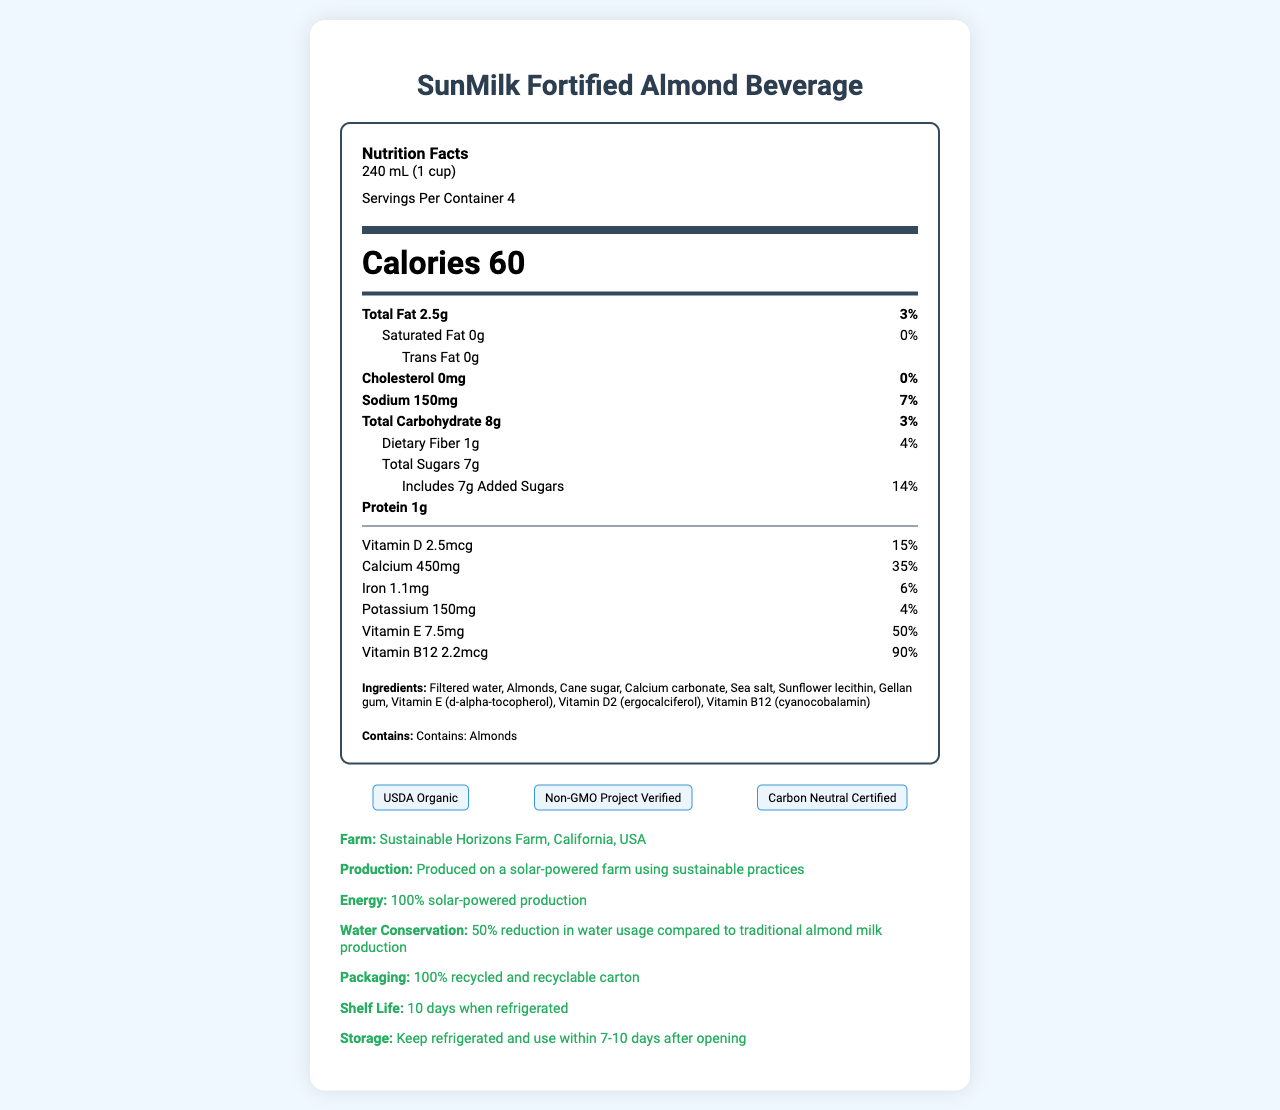what is the serving size of SunMilk Fortified Almond Beverage? The serving size is listed at the top of the nutrition facts section as "240 mL (1 cup)".
Answer: 240 mL (1 cup) How many servings are there per container? The number of servings per container is specified as "Servings Per Container: 4".
Answer: 4 How many calories are in one serving of this beverage? The calorie count per serving is displayed prominently in a larger font as "Calories 60".
Answer: 60 What is the daily value percentage of Vitamin D? The daily value percentage of Vitamin D is listed under the vitamin section as "Vitamin D 2.5mcg 15%".
Answer: 15% How much added sugar is in one serving? Under "Total Sugars", it is specified that there are "Includes 7g Added Sugars".
Answer: 7g Which vitamin has the highest daily value percentage in this beverage? Vitamin B12 has the highest daily value percentage of 90%, as shown in the document.
Answer: Vitamin B12 What certifications does this product have? A. USDA Organic B. Non-GMO Project Verified C. Carbon Neutral Certified D. All of the above The certifications section lists all three certifications: "USDA Organic", "Non-GMO Project Verified", and "Carbon Neutral Certified".
Answer: D. All of the above What is the main ingredient of SunMilk Fortified Almond Beverage? A. Cane sugar B. Almonds C. Filtered water The ingredients list shows "Filtered water" as the first ingredient, making it the main component.
Answer: C. Filtered water Does this beverage contain any saturated fat? The nutrition facts indicate "Saturated Fat 0g" and "0%" daily value, implying there is none.
Answer: No Is this product suitable for those who are allergic to almonds? The allergen statement explicitly states "Contains: Almonds", indicating it is not suitable for those with almond allergies.
Answer: No Where is the solar-powered farm located that produces this beverage? The farm location mentioned in the farm info section is "Sustainable Horizons Farm, California, USA".
Answer: Sustainable Horizons Farm, California, USA What is the overall environmental impact of the packaging used for this beverage? The document states that the packaging is "100% recycled and recyclable carton".
Answer: 100% recycled and recyclable carton Can the shelf life data of this product be confirmed from the document? The document specifies a shelf life of "10 days when refrigerated".
Answer: Yes Summarize the main points of this document. The document centers on nutritional information, sustainability practices of the farm, certifications, allergen information, and other product-related details, highlighting both its health benefits and environmental credentials.
Answer: The document provides detailed nutrition facts and ingredient lists for SunMilk Fortified Almond Beverage, a fortified almond milk produced sustainably on a solar-powered farm. Key nutrition information includes 60 calories per serving, 2.5g total fat, 7g added sugars, and high percentages of vitamins B12 (90%) and E (50%). The drink is USDA Organic, Non-GMO Project Verified, and Carbon Neutral Certified. It contains almonds, comes in a 100% recycled carton, has a shelf life of 10 days refrigerated, and is produced with 100% solar energy and reduced water usage. How much potassium is in a single serving of SunMilk Fortified Almond Beverage? The amount of potassium per serving is listed as "Potassium 150mg".
Answer: 150mg Does this beverage contain cholesterol? The document states "Cholesterol 0mg" and "0%" daily value, indicating no cholesterol content.
Answer: No What is the distribution method used for this almond beverage? The document does not provide information about the distribution method of the beverage.
Answer: Cannot be determined 